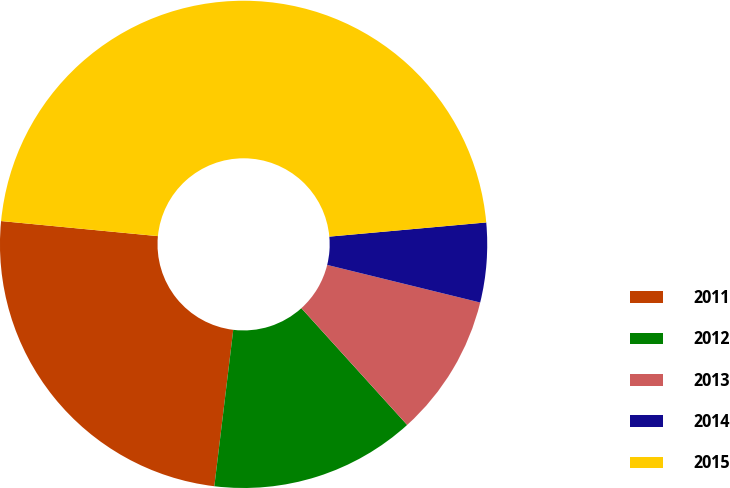Convert chart to OTSL. <chart><loc_0><loc_0><loc_500><loc_500><pie_chart><fcel>2011<fcel>2012<fcel>2013<fcel>2014<fcel>2015<nl><fcel>24.61%<fcel>13.63%<fcel>9.45%<fcel>5.27%<fcel>47.04%<nl></chart> 